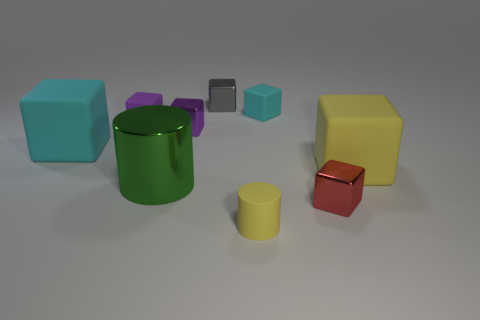What number of other things are the same size as the purple rubber object?
Provide a short and direct response. 5. There is a tiny thing that is both on the left side of the small cyan rubber cube and in front of the big green metallic cylinder; what material is it made of?
Provide a succinct answer. Rubber. Does the big shiny cylinder have the same color as the object in front of the red cube?
Your answer should be compact. No. There is a yellow rubber object that is the same shape as the large metallic thing; what is its size?
Provide a succinct answer. Small. The large object that is in front of the big cyan block and to the left of the matte cylinder has what shape?
Offer a very short reply. Cylinder. There is a yellow matte cube; is it the same size as the metallic object in front of the big green cylinder?
Provide a succinct answer. No. There is another small matte object that is the same shape as the tiny purple matte thing; what color is it?
Make the answer very short. Cyan. Does the cylinder that is behind the small yellow thing have the same size as the cyan matte thing on the left side of the yellow rubber cylinder?
Keep it short and to the point. Yes. Is the shape of the red object the same as the big green metal thing?
Your answer should be compact. No. What number of objects are either big matte blocks to the right of the small cyan object or cyan blocks?
Your answer should be compact. 3. 